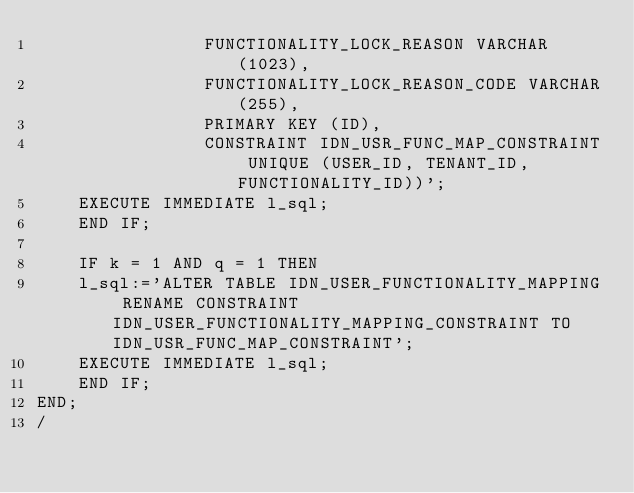Convert code to text. <code><loc_0><loc_0><loc_500><loc_500><_SQL_>	            FUNCTIONALITY_LOCK_REASON VARCHAR(1023),
	            FUNCTIONALITY_LOCK_REASON_CODE VARCHAR(255),
	            PRIMARY KEY (ID),
	            CONSTRAINT IDN_USR_FUNC_MAP_CONSTRAINT UNIQUE (USER_ID, TENANT_ID, FUNCTIONALITY_ID))';
    EXECUTE IMMEDIATE l_sql;
    END IF;

    IF k = 1 AND q = 1 THEN
    l_sql:='ALTER TABLE IDN_USER_FUNCTIONALITY_MAPPING RENAME CONSTRAINT IDN_USER_FUNCTIONALITY_MAPPING_CONSTRAINT TO IDN_USR_FUNC_MAP_CONSTRAINT';
    EXECUTE IMMEDIATE l_sql;
    END IF;
END;
/
</code> 